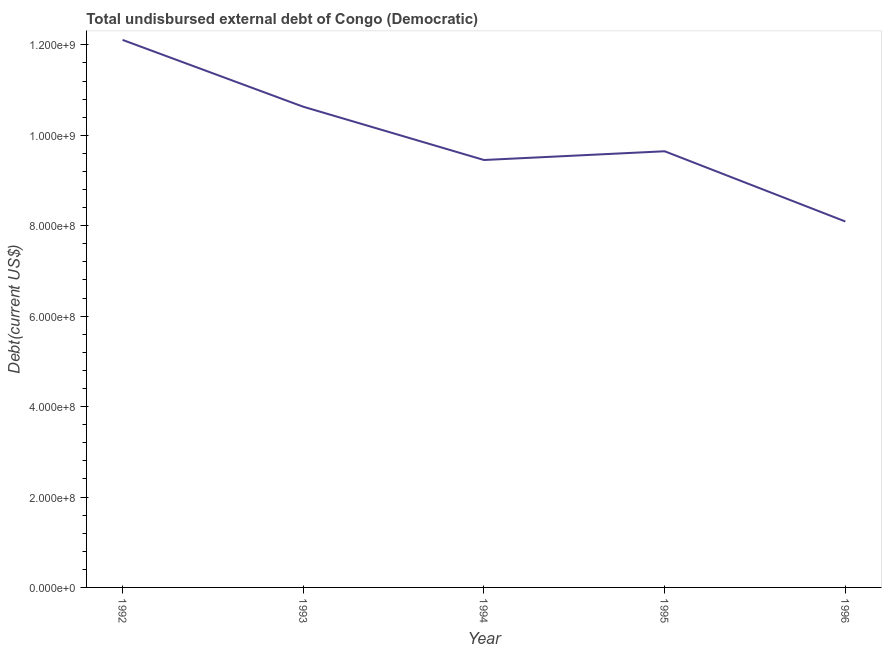What is the total debt in 1994?
Keep it short and to the point. 9.45e+08. Across all years, what is the maximum total debt?
Your response must be concise. 1.21e+09. Across all years, what is the minimum total debt?
Your answer should be very brief. 8.09e+08. In which year was the total debt maximum?
Your response must be concise. 1992. In which year was the total debt minimum?
Provide a short and direct response. 1996. What is the sum of the total debt?
Give a very brief answer. 4.99e+09. What is the difference between the total debt in 1994 and 1995?
Provide a succinct answer. -1.93e+07. What is the average total debt per year?
Your answer should be very brief. 9.99e+08. What is the median total debt?
Give a very brief answer. 9.65e+08. Do a majority of the years between 1995 and 1996 (inclusive) have total debt greater than 400000000 US$?
Your response must be concise. Yes. What is the ratio of the total debt in 1993 to that in 1995?
Your answer should be compact. 1.1. What is the difference between the highest and the second highest total debt?
Provide a succinct answer. 1.48e+08. What is the difference between the highest and the lowest total debt?
Make the answer very short. 4.02e+08. How many years are there in the graph?
Your answer should be very brief. 5. What is the title of the graph?
Provide a succinct answer. Total undisbursed external debt of Congo (Democratic). What is the label or title of the X-axis?
Ensure brevity in your answer.  Year. What is the label or title of the Y-axis?
Provide a short and direct response. Debt(current US$). What is the Debt(current US$) of 1992?
Provide a succinct answer. 1.21e+09. What is the Debt(current US$) in 1993?
Provide a succinct answer. 1.06e+09. What is the Debt(current US$) of 1994?
Keep it short and to the point. 9.45e+08. What is the Debt(current US$) in 1995?
Your answer should be compact. 9.65e+08. What is the Debt(current US$) of 1996?
Make the answer very short. 8.09e+08. What is the difference between the Debt(current US$) in 1992 and 1993?
Provide a succinct answer. 1.48e+08. What is the difference between the Debt(current US$) in 1992 and 1994?
Offer a very short reply. 2.66e+08. What is the difference between the Debt(current US$) in 1992 and 1995?
Your answer should be very brief. 2.46e+08. What is the difference between the Debt(current US$) in 1992 and 1996?
Offer a terse response. 4.02e+08. What is the difference between the Debt(current US$) in 1993 and 1994?
Provide a succinct answer. 1.18e+08. What is the difference between the Debt(current US$) in 1993 and 1995?
Provide a short and direct response. 9.85e+07. What is the difference between the Debt(current US$) in 1993 and 1996?
Your response must be concise. 2.54e+08. What is the difference between the Debt(current US$) in 1994 and 1995?
Your answer should be compact. -1.93e+07. What is the difference between the Debt(current US$) in 1994 and 1996?
Ensure brevity in your answer.  1.36e+08. What is the difference between the Debt(current US$) in 1995 and 1996?
Make the answer very short. 1.55e+08. What is the ratio of the Debt(current US$) in 1992 to that in 1993?
Your answer should be compact. 1.14. What is the ratio of the Debt(current US$) in 1992 to that in 1994?
Make the answer very short. 1.28. What is the ratio of the Debt(current US$) in 1992 to that in 1995?
Your answer should be very brief. 1.25. What is the ratio of the Debt(current US$) in 1992 to that in 1996?
Your response must be concise. 1.5. What is the ratio of the Debt(current US$) in 1993 to that in 1994?
Make the answer very short. 1.12. What is the ratio of the Debt(current US$) in 1993 to that in 1995?
Your answer should be compact. 1.1. What is the ratio of the Debt(current US$) in 1993 to that in 1996?
Give a very brief answer. 1.31. What is the ratio of the Debt(current US$) in 1994 to that in 1995?
Offer a terse response. 0.98. What is the ratio of the Debt(current US$) in 1994 to that in 1996?
Provide a succinct answer. 1.17. What is the ratio of the Debt(current US$) in 1995 to that in 1996?
Give a very brief answer. 1.19. 